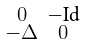Convert formula to latex. <formula><loc_0><loc_0><loc_500><loc_500>\begin{smallmatrix} 0 & - \text {Id} \\ - \Delta & 0 \end{smallmatrix}</formula> 